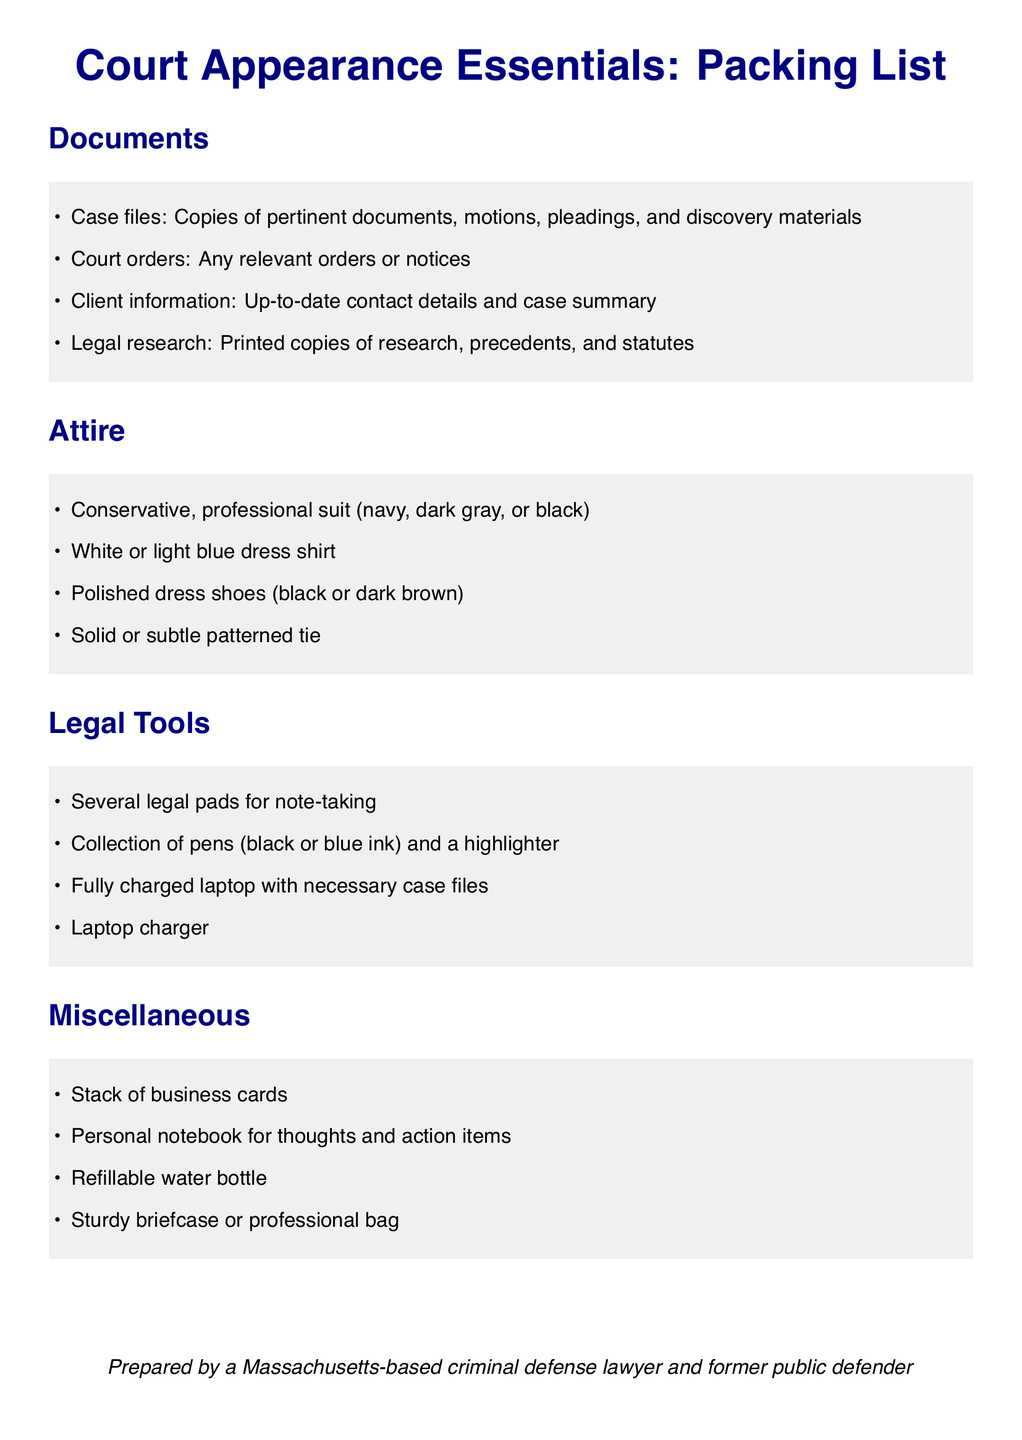What is the first item listed under Documents? The first item listed under Documents refers to the pertinent documents related to the case that the lawyer will need to bring.
Answer: Case files: Copies of pertinent documents, motions, pleadings, and discovery materials What color should the dress shirt be? The document specifies that the dress shirt should be of light color, mentioning specific colors.
Answer: White or light blue dress shirt How many legal pads are suggested to bring? The document indicates several pads, suggesting an adequate amount for note-taking.
Answer: Several legal pads What should the lawyer carry for personal thoughts? The document mentions an item for jotting down personal thoughts and action items.
Answer: Personal notebook for thoughts and action items What type of bag is recommended? The recommended bag for carrying court essentials is mentioned explicitly in the document.
Answer: Sturdy briefcase or professional bag How many types of ink pens are listed? The document lists specific colors for pens that should be brought to court.
Answer: Two (black or blue) What is the theme color choice for the suit? The document specifies colors for professional attire, which include darker shades.
Answer: Navy, dark gray, or black What is included in the Miscellaneous section for hydration? The document specifies an item that reinforces the importance of staying hydrated during court appearances.
Answer: Refillable water bottle 